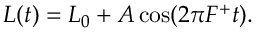Convert formula to latex. <formula><loc_0><loc_0><loc_500><loc_500>\begin{array} { r } { L ( t ) = L _ { 0 } + A \cos ( 2 \pi F ^ { + } t ) . } \end{array}</formula> 